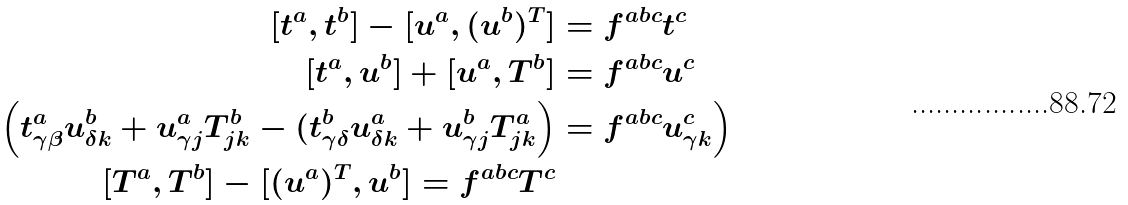Convert formula to latex. <formula><loc_0><loc_0><loc_500><loc_500>[ t ^ { a } , t ^ { b } ] - [ u ^ { a } , ( u ^ { b } ) ^ { T } ] & = f ^ { a b c } t ^ { c } \\ [ t ^ { a } , u ^ { b } ] + [ u ^ { a } , T ^ { b } ] & = f ^ { a b c } u ^ { c } \\ \Big ( t ^ { a } _ { \gamma \beta } u ^ { b } _ { \delta k } + u ^ { a } _ { \gamma j } T ^ { b } _ { j k } - ( t ^ { b } _ { \gamma \delta } u ^ { a } _ { \delta k } + u ^ { b } _ { \gamma j } T ^ { a } _ { j k } \Big ) & = f ^ { a b c } u ^ { c } _ { \gamma k } \Big ) \\ [ T ^ { a } , T ^ { b } ] - [ ( u ^ { a } ) ^ { T } , u ^ { b } ] = f ^ { a b c } T ^ { c }</formula> 